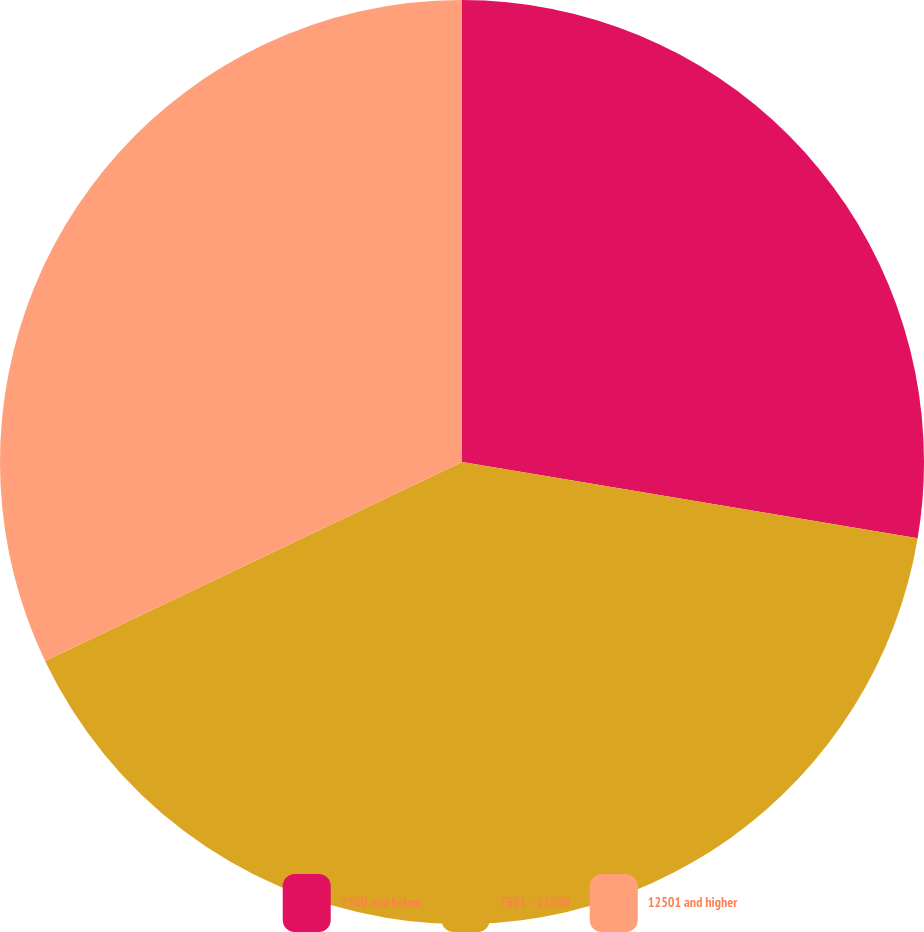Convert chart. <chart><loc_0><loc_0><loc_500><loc_500><pie_chart><fcel>7500 and below<fcel>7501 - 12500<fcel>12501 and higher<nl><fcel>27.64%<fcel>40.27%<fcel>32.09%<nl></chart> 